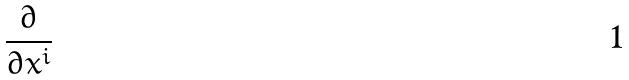Convert formula to latex. <formula><loc_0><loc_0><loc_500><loc_500>\frac { \partial } { \partial x ^ { i } }</formula> 